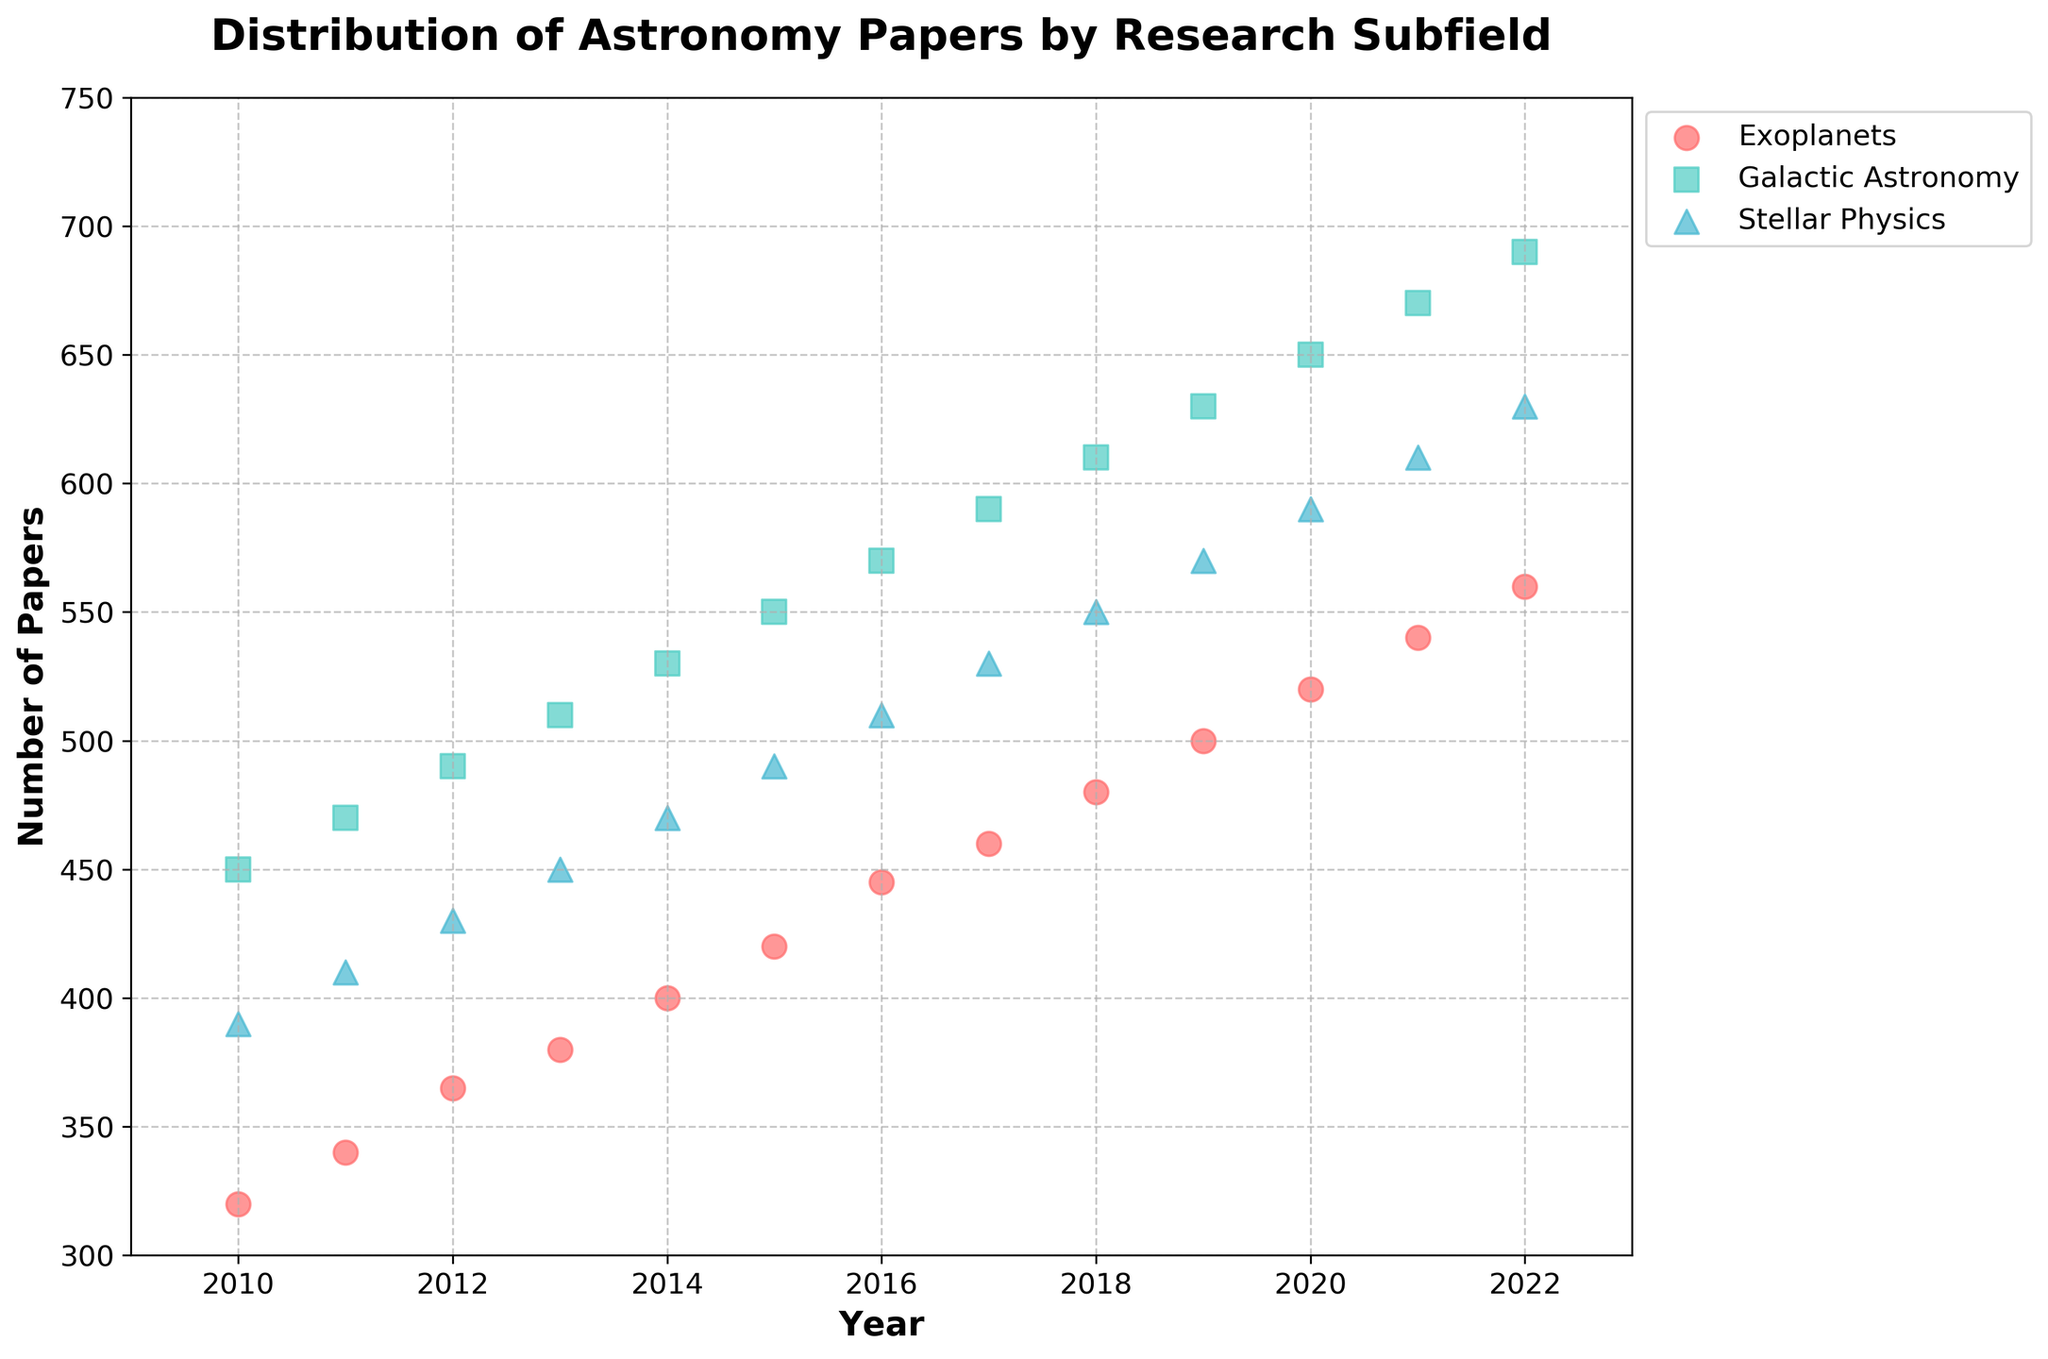What is the title of the figure? The title of the figure is typically located at the top of the plot and provides a summary of what the plot represents. By looking at the figure, you can see the title.
Answer: Distribution of Astronomy Papers by Research Subfield What are the labels for the x-axis and y-axis? The x-axis and y-axis labels provide context for the data being presented. They are located along the respective axes.
Answer: x-axis: Year, y-axis: Number of Papers Which research subfield published the most papers in 2020? To find the subfield with the most papers in 2020, locate the year 2020 on the x-axis and check the corresponding points for each subfield on the plot to compare their y-values.
Answer: Galactic Astronomy How has the number of papers published in the Exoplanets subfield changed from 2010 to 2022? To determine the change over time, look at the points corresponding to Exoplanets for 2010 and 2022, then compare their y-values to understand the increase or decrease in number of papers.
Answer: Increased from 320 to 560 Which year saw the highest total number of papers published across all subfields? To find this, sum the number of papers for all subfields for each year by visually adding the y-values of all points for each year, then compare these sums to identify the highest.
Answer: 2022 What is the average number of papers published in the Stellar Physics subfield from 2015 to 2020? Calculate the average by adding the number of papers for Stellar Physics for the years 2015 through 2020 and dividing by the number of years.
Answer: (490 + 510 + 530 + 550 + 570 + 590) / 6 = 540 Which subfield shows the most consistent increase in the number of papers published per year? Consistency in increase can be determined by observing the trend lines formed by the data points of each subfield and checking which one has the smoothest upward trajectory without large fluctuations.
Answer: Galactic Astronomy In which year did the Stellar Physics subfield publish fewer papers than the Exoplanets subfield, if any? Compare the y-values of the data points for Stellar Physics and Exoplanets for each year to find any year where Stellar Physics has a lower number.
Answer: 2010 If the trend continues, how many papers do you estimate will be published in the Exoplanets subfield in 2023? Identify the trend line for Exoplanets from previous years and extend it to estimate the number in 2023, taking into account the average yearly increase.
Answer: Approximately 580 Which subfield had the greatest increase in the number of papers published from 2010 to 2022? Subtract the number of papers in 2010 from the number in 2022 for each subfield and compare the results to find the greatest increase.
Answer: Galactic Astronomy 